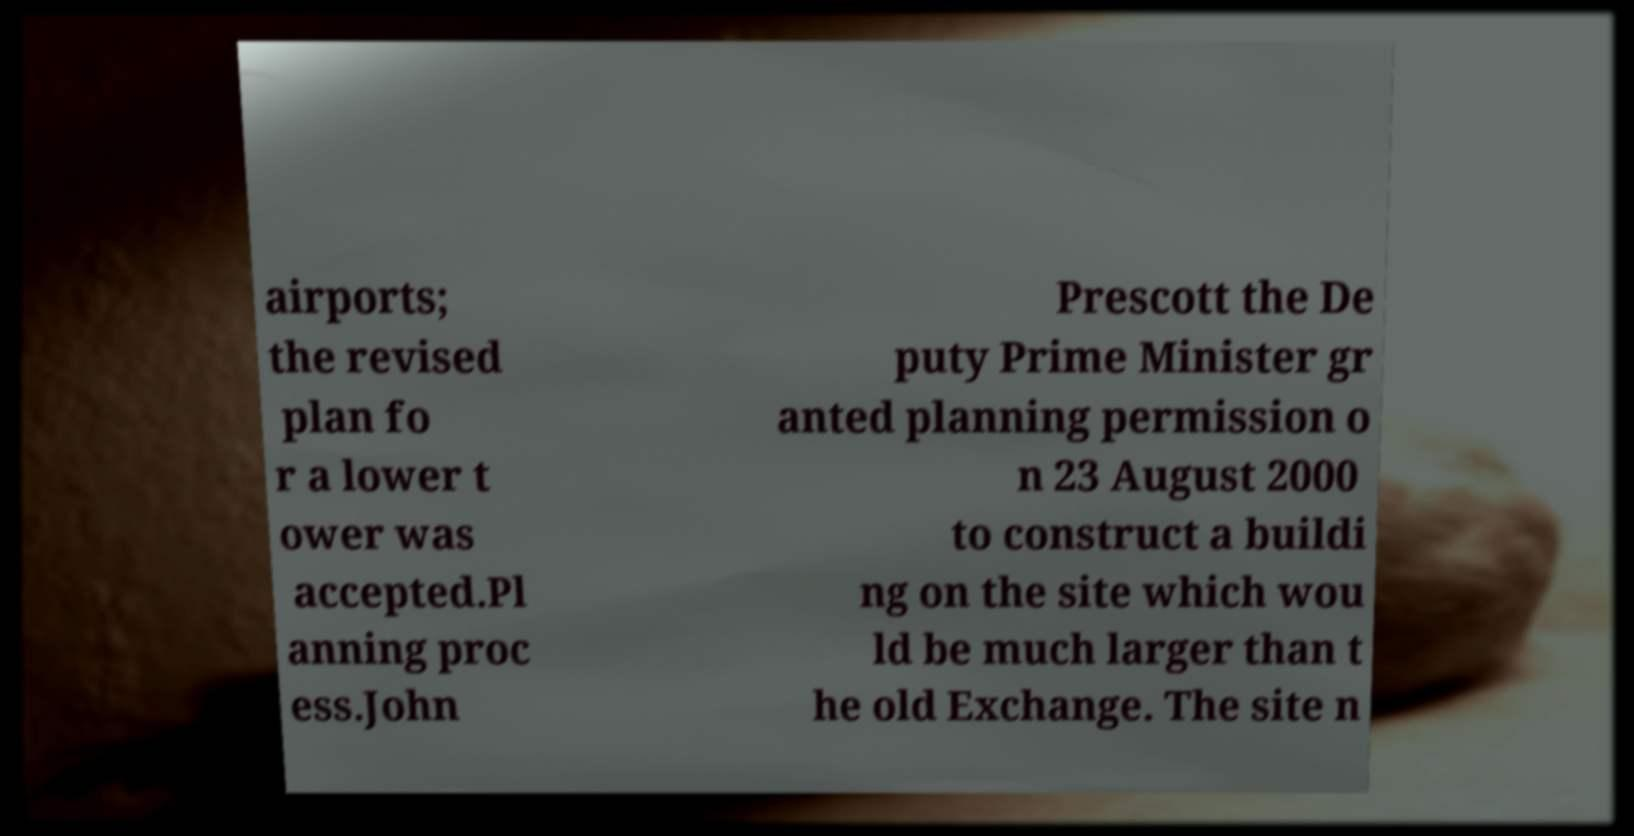Please read and relay the text visible in this image. What does it say? airports; the revised plan fo r a lower t ower was accepted.Pl anning proc ess.John Prescott the De puty Prime Minister gr anted planning permission o n 23 August 2000 to construct a buildi ng on the site which wou ld be much larger than t he old Exchange. The site n 